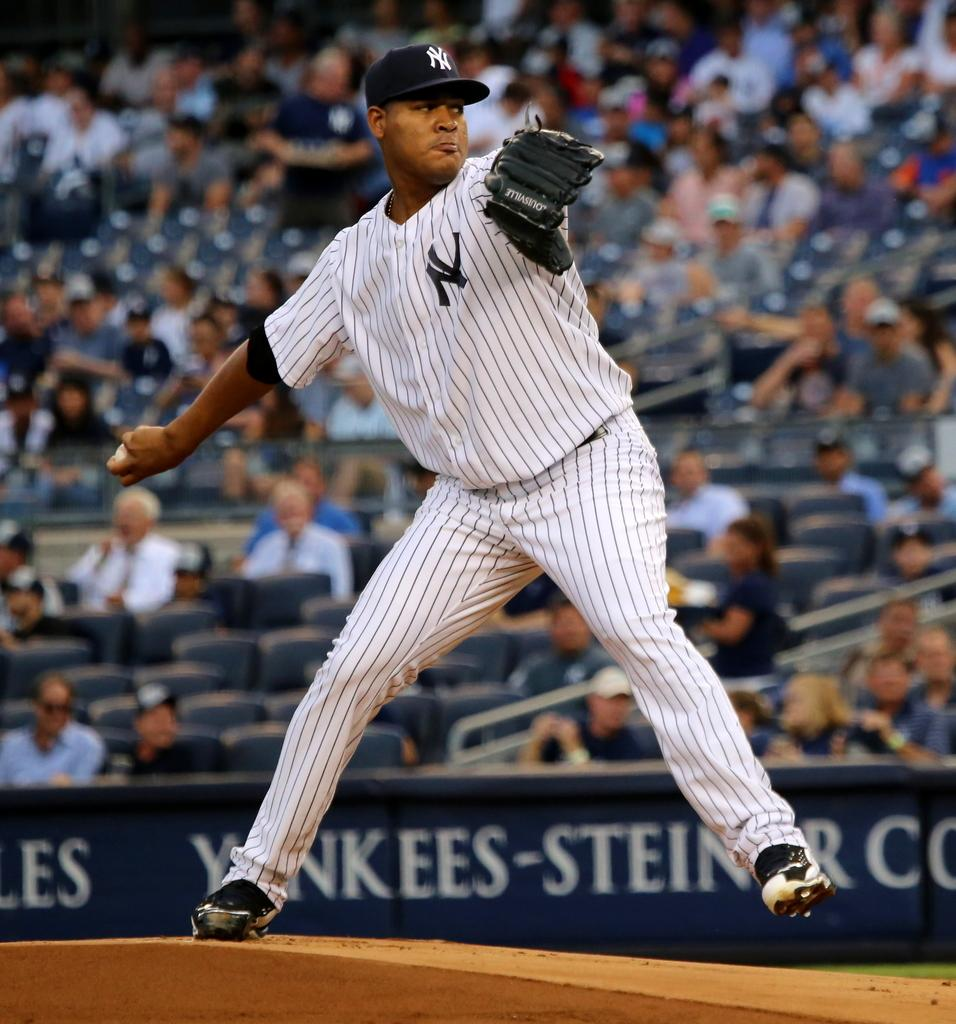<image>
Present a compact description of the photo's key features. a player with a Yankees hat on and a Yankees-Steiner ad behind them 